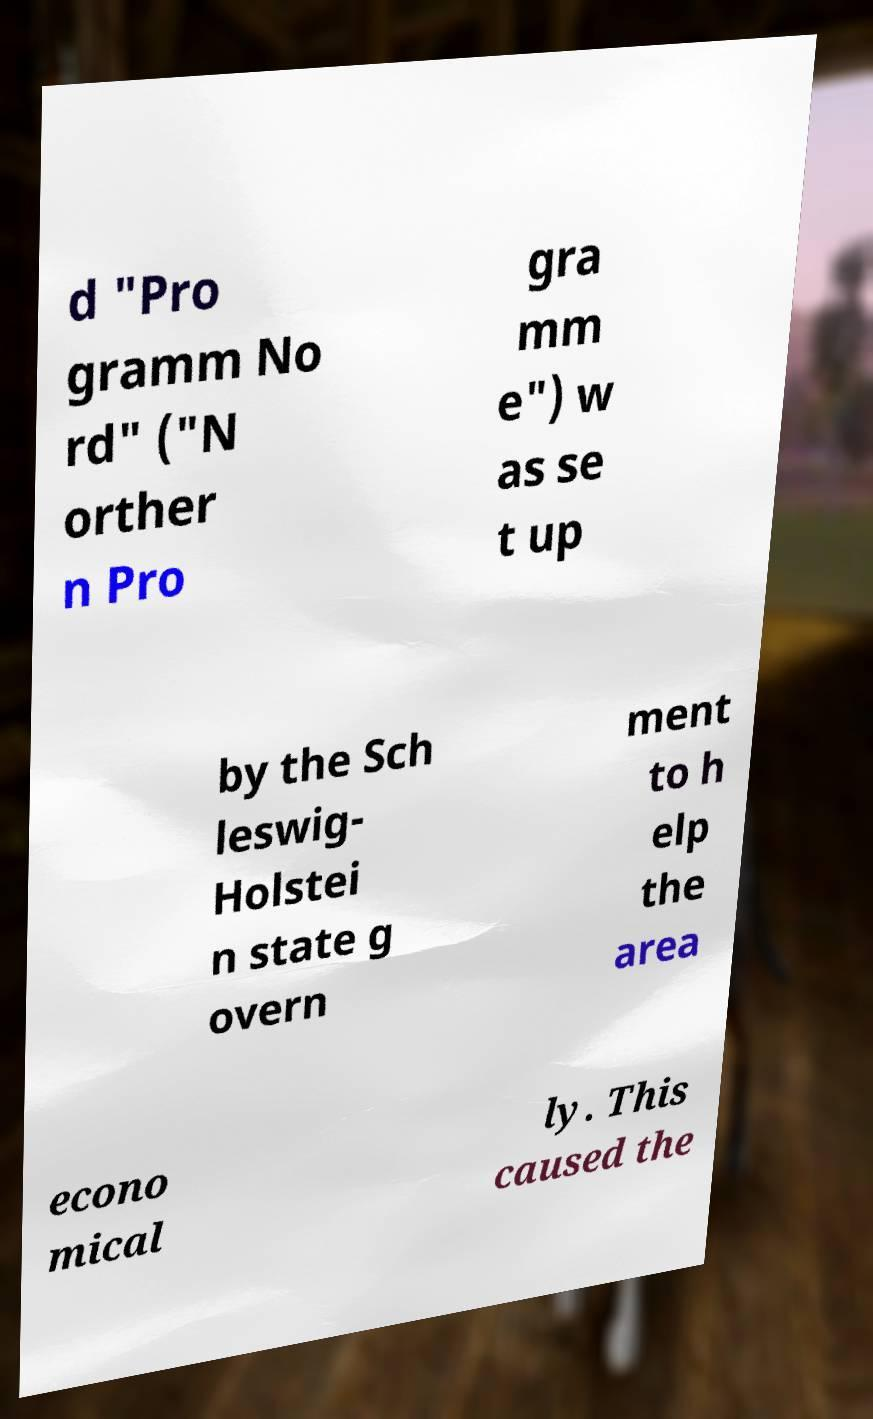For documentation purposes, I need the text within this image transcribed. Could you provide that? d "Pro gramm No rd" ("N orther n Pro gra mm e") w as se t up by the Sch leswig- Holstei n state g overn ment to h elp the area econo mical ly. This caused the 